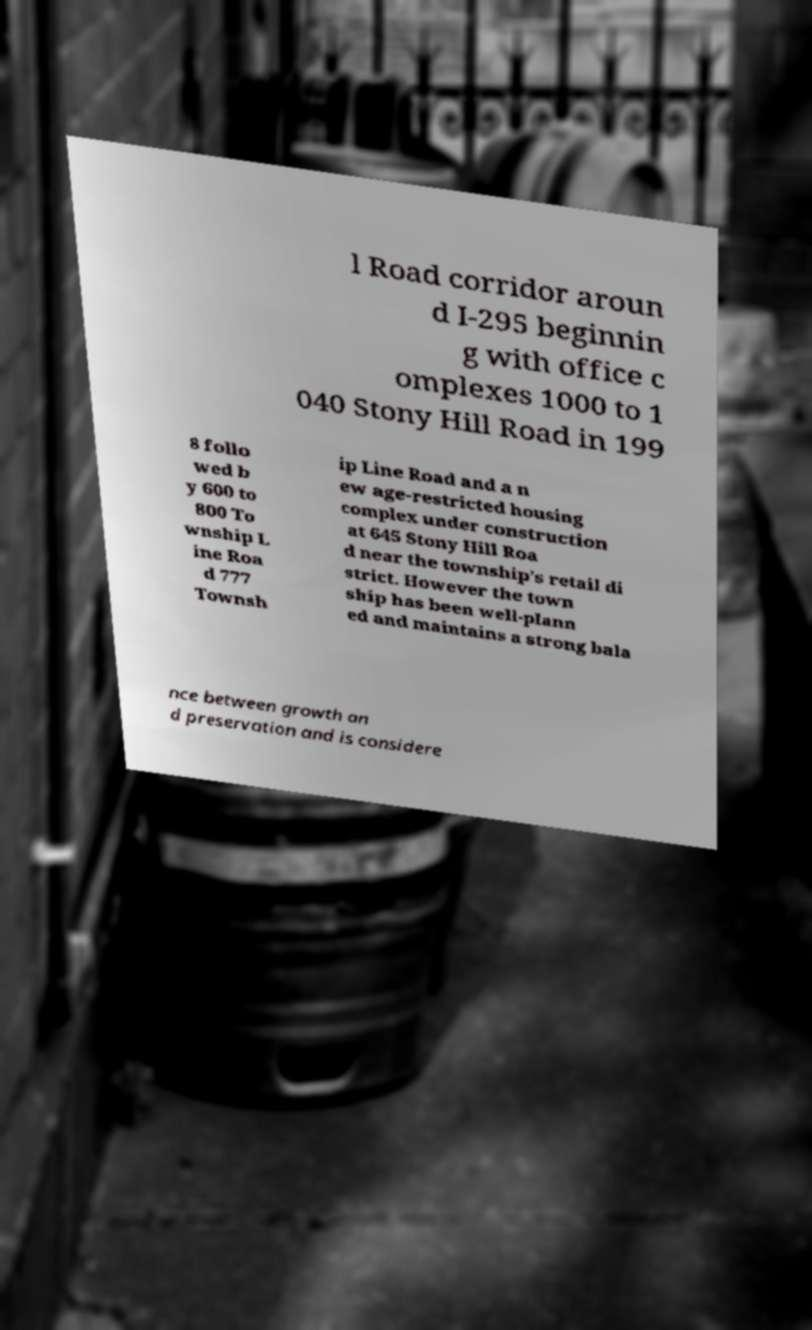Please identify and transcribe the text found in this image. l Road corridor aroun d I-295 beginnin g with office c omplexes 1000 to 1 040 Stony Hill Road in 199 8 follo wed b y 600 to 800 To wnship L ine Roa d 777 Townsh ip Line Road and a n ew age-restricted housing complex under construction at 645 Stony Hill Roa d near the township's retail di strict. However the town ship has been well-plann ed and maintains a strong bala nce between growth an d preservation and is considere 